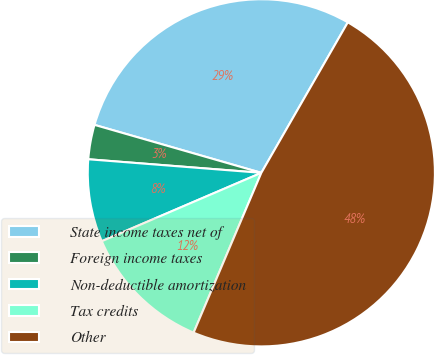Convert chart to OTSL. <chart><loc_0><loc_0><loc_500><loc_500><pie_chart><fcel>State income taxes net of<fcel>Foreign income taxes<fcel>Non-deductible amortization<fcel>Tax credits<fcel>Other<nl><fcel>28.85%<fcel>3.21%<fcel>7.69%<fcel>12.18%<fcel>48.08%<nl></chart> 